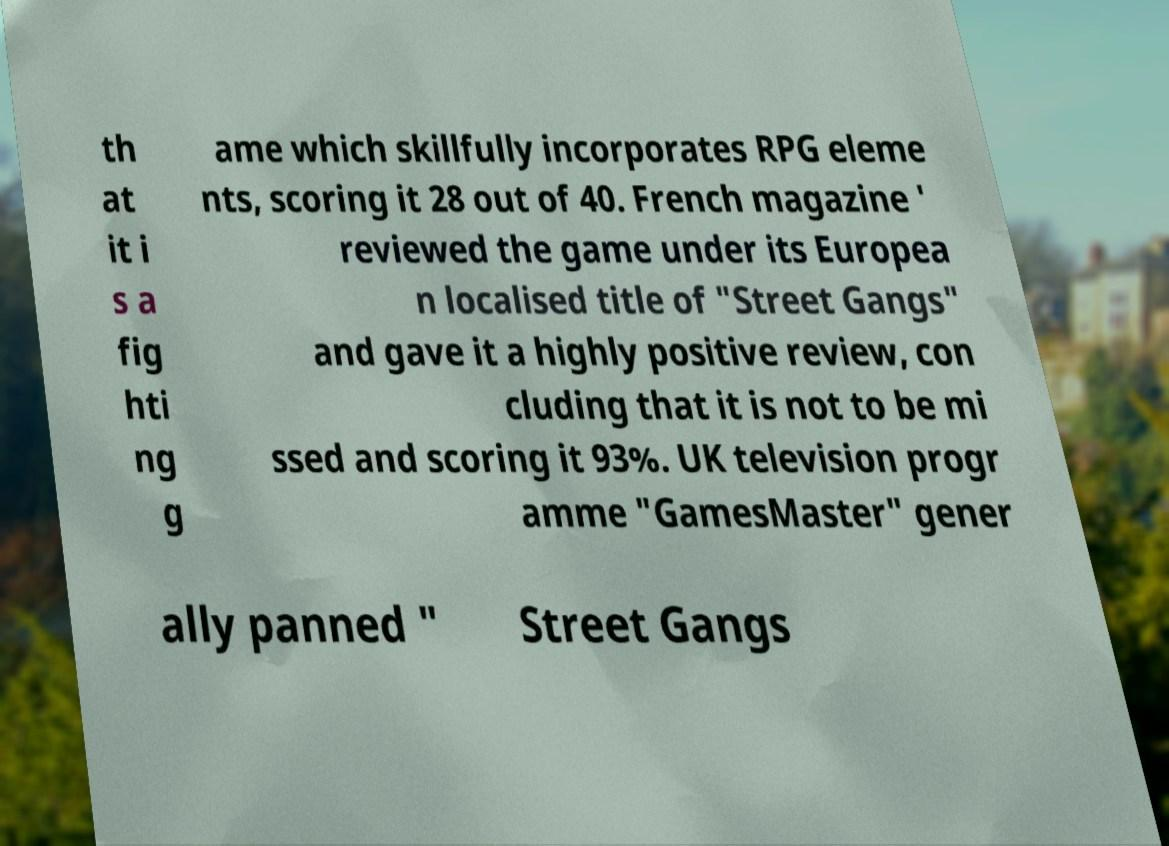What messages or text are displayed in this image? I need them in a readable, typed format. th at it i s a fig hti ng g ame which skillfully incorporates RPG eleme nts, scoring it 28 out of 40. French magazine ' reviewed the game under its Europea n localised title of "Street Gangs" and gave it a highly positive review, con cluding that it is not to be mi ssed and scoring it 93%. UK television progr amme "GamesMaster" gener ally panned " Street Gangs 